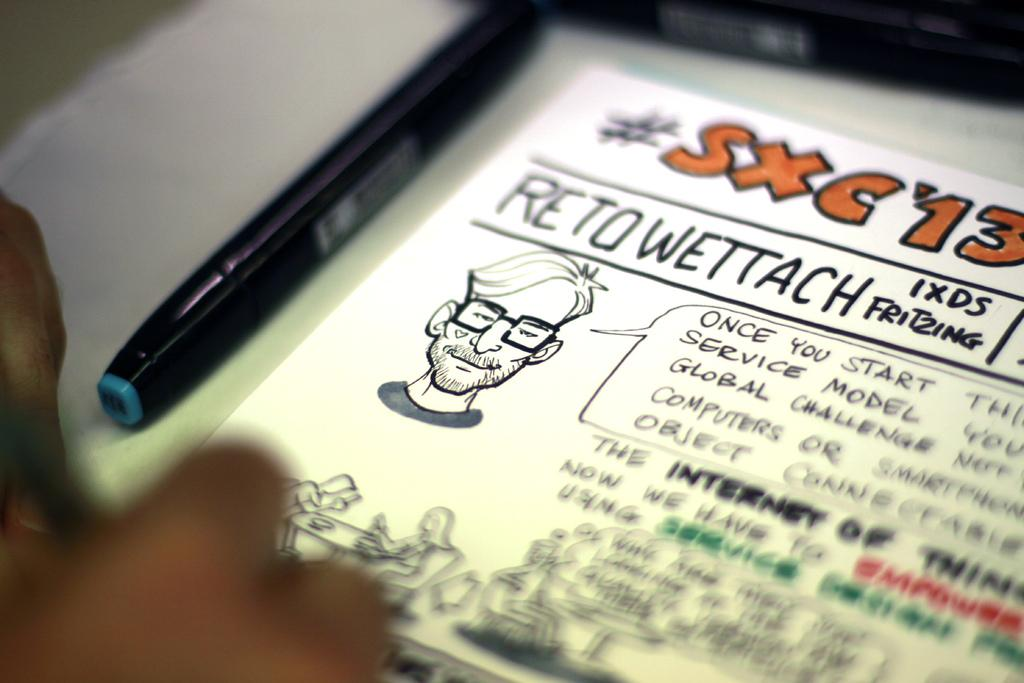What part of a person can be seen in the image? There is a person's hand in the image. What is the person holding in the image? The person is holding a paper with text in the image. What is depicted on the paper? The paper contains a person's depiction. What might the person be using to write or draw on the paper? There is a pen in the image. What is the person's reaction to the start of the theory in the image? There is no indication of a theory or a reaction in the image; it only shows a person's hand holding a paper with a person's depiction on it. 